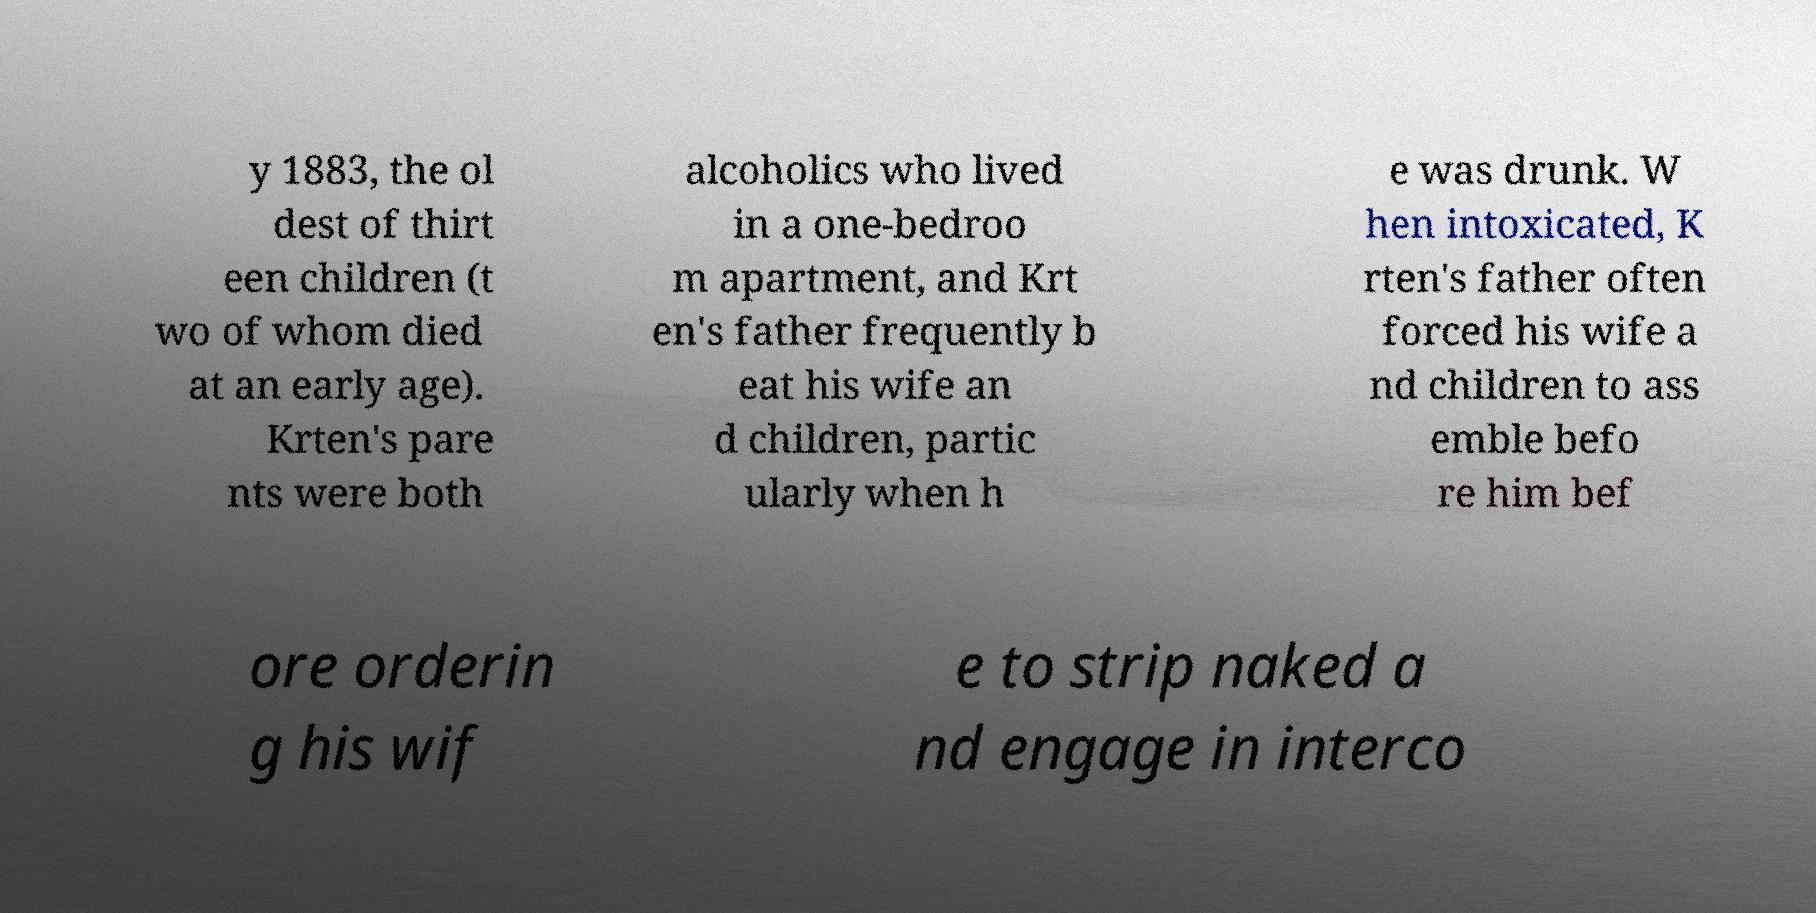Can you read and provide the text displayed in the image?This photo seems to have some interesting text. Can you extract and type it out for me? y 1883, the ol dest of thirt een children (t wo of whom died at an early age). Krten's pare nts were both alcoholics who lived in a one-bedroo m apartment, and Krt en's father frequently b eat his wife an d children, partic ularly when h e was drunk. W hen intoxicated, K rten's father often forced his wife a nd children to ass emble befo re him bef ore orderin g his wif e to strip naked a nd engage in interco 